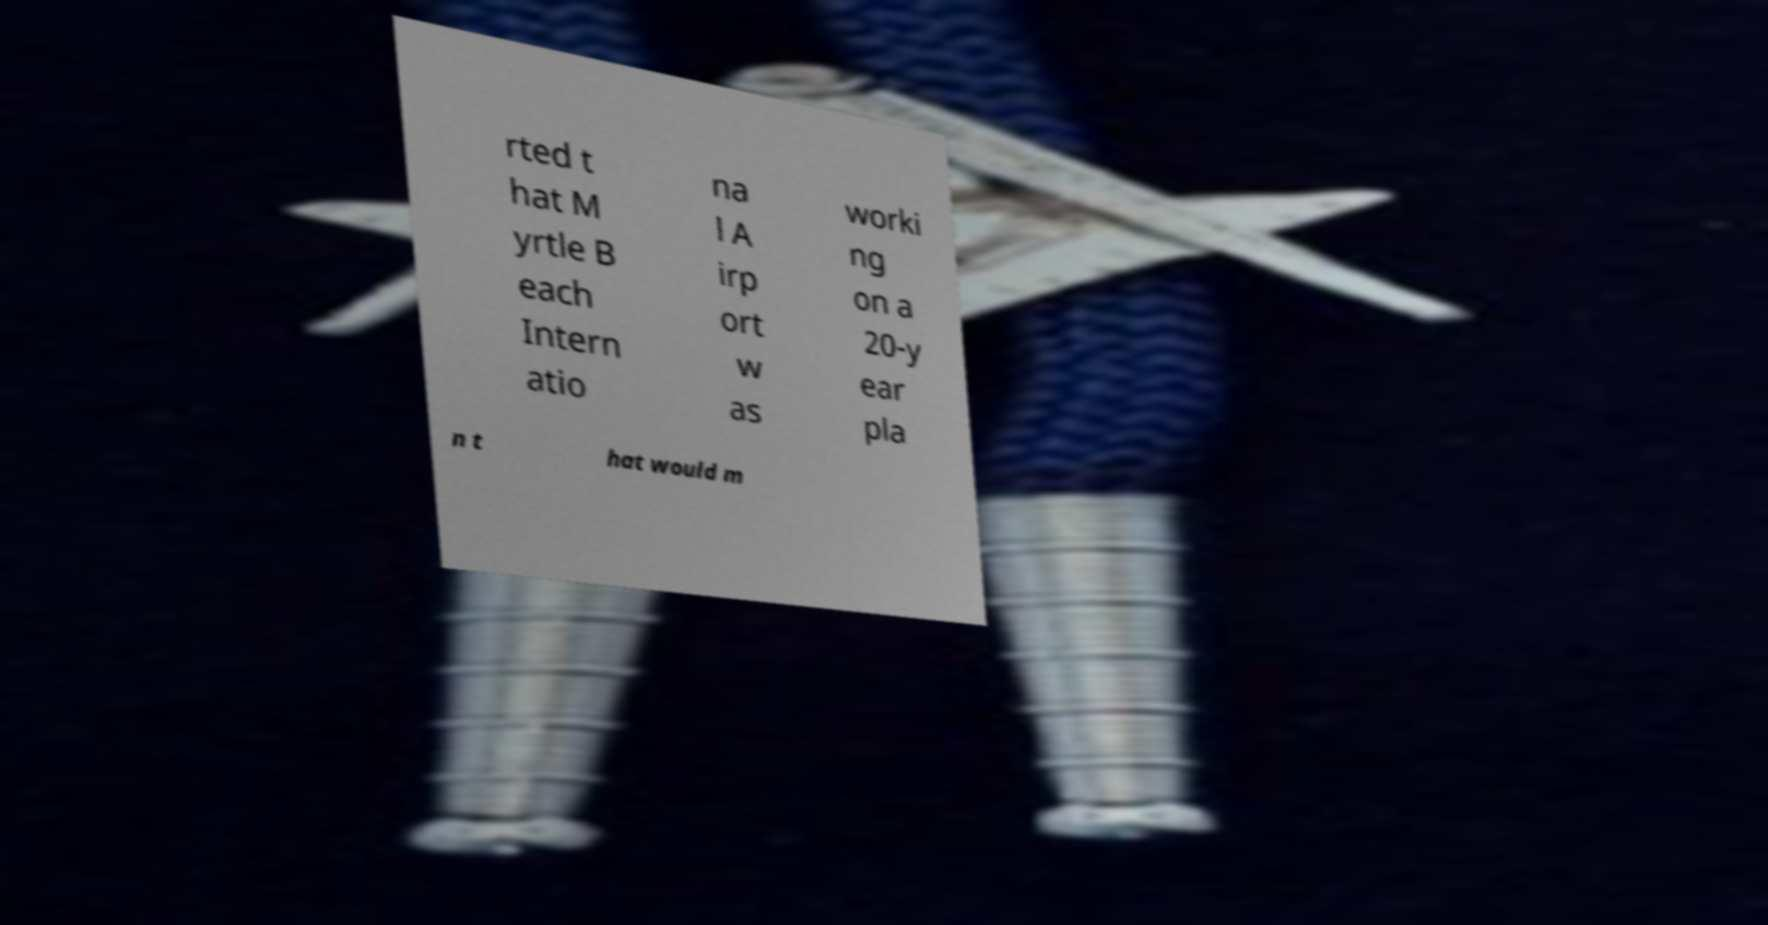I need the written content from this picture converted into text. Can you do that? rted t hat M yrtle B each Intern atio na l A irp ort w as worki ng on a 20-y ear pla n t hat would m 